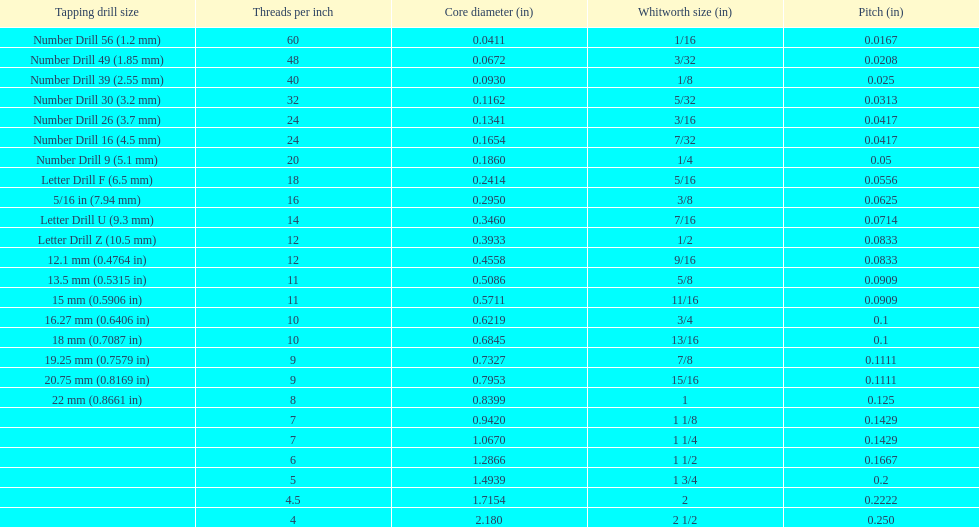What core diameter (in) comes after 0.0930? 0.1162. 